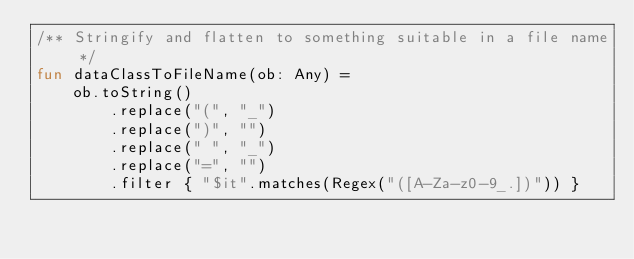<code> <loc_0><loc_0><loc_500><loc_500><_Kotlin_>/** Stringify and flatten to something suitable in a file name */
fun dataClassToFileName(ob: Any) =
    ob.toString()
        .replace("(", "_")
        .replace(")", "")
        .replace(" ", "_")
        .replace("=", "")
        .filter { "$it".matches(Regex("([A-Za-z0-9_.])")) }
</code> 